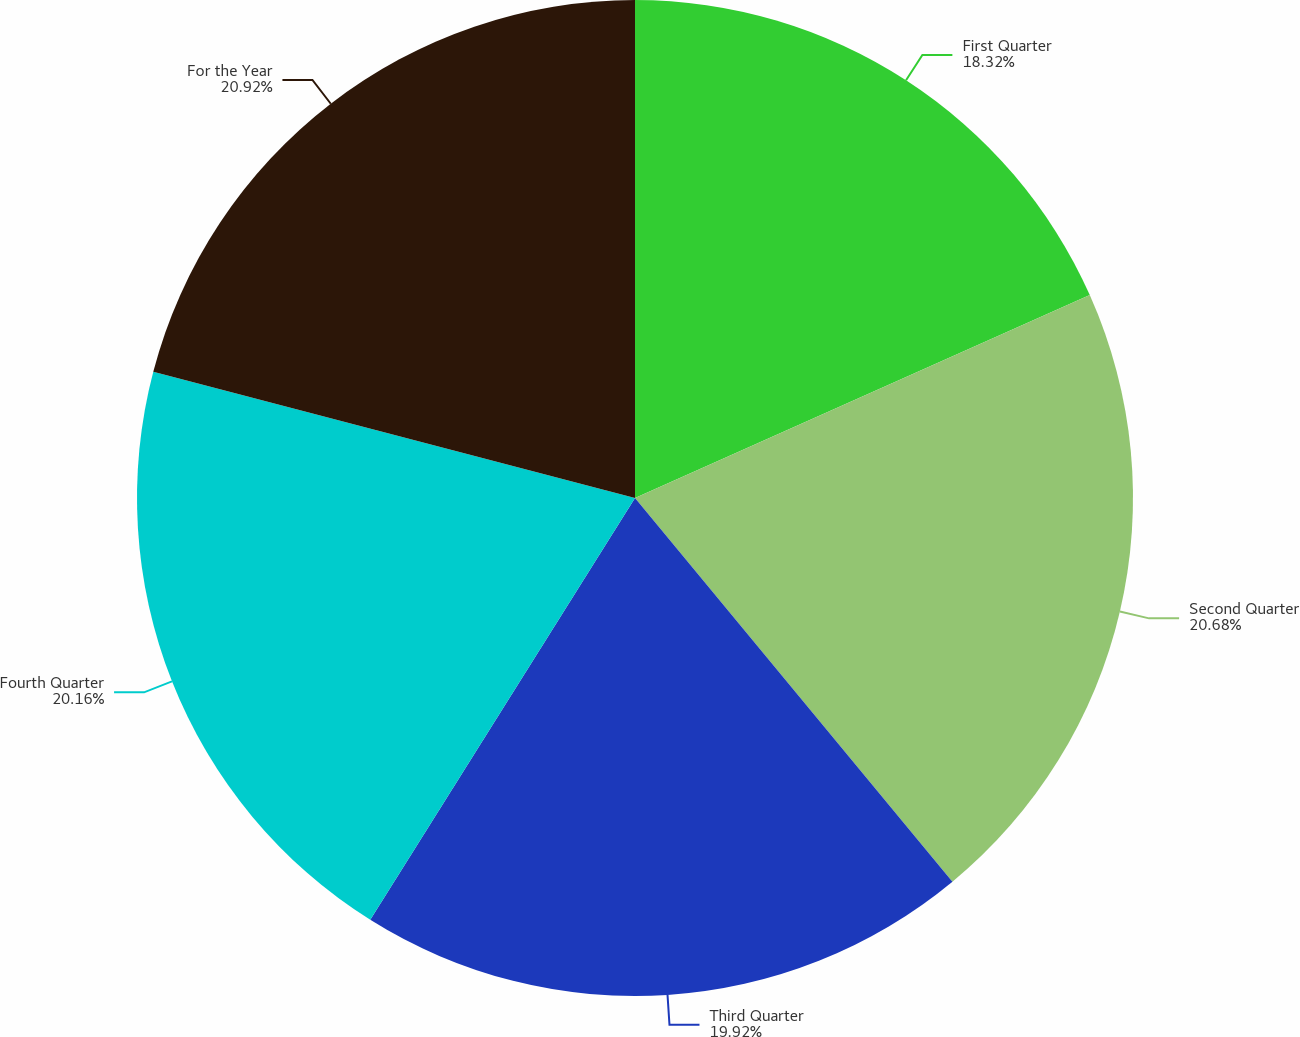Convert chart. <chart><loc_0><loc_0><loc_500><loc_500><pie_chart><fcel>First Quarter<fcel>Second Quarter<fcel>Third Quarter<fcel>Fourth Quarter<fcel>For the Year<nl><fcel>18.32%<fcel>20.68%<fcel>19.92%<fcel>20.16%<fcel>20.92%<nl></chart> 